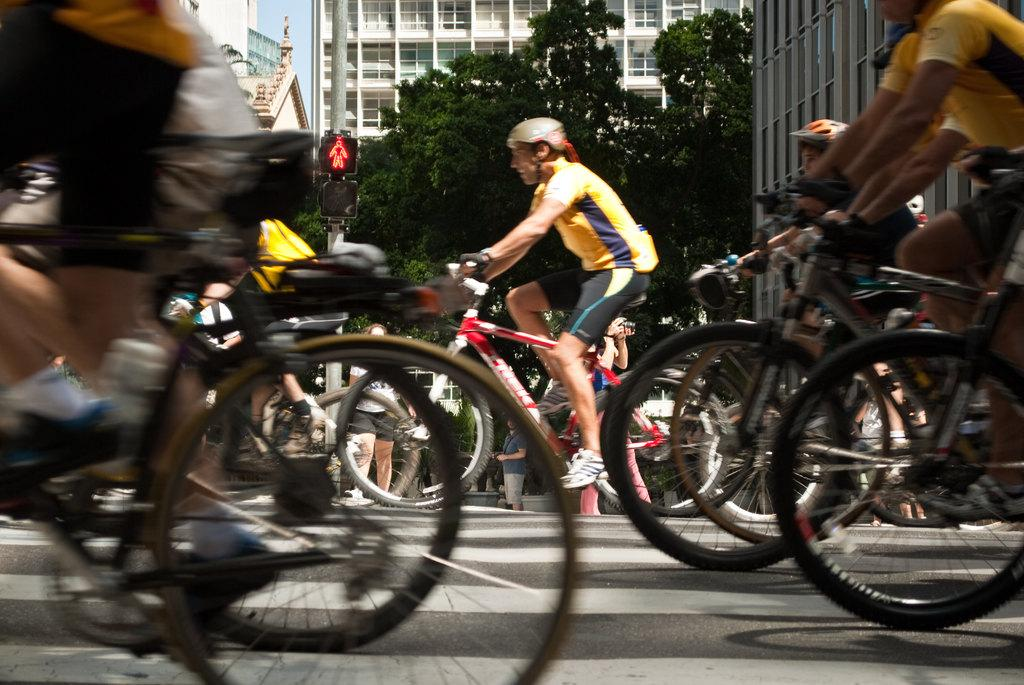What are the people in the image doing? The people in the image are riding bicycles on the road. What can be seen behind the people riding bicycles? There are trees and buildings behind the people riding bicycles. Can you see a river in the image? There is no river visible in the image. What type of shoe is the person riding the bicycle wearing? The image does not show the shoes of the people riding bicycles, so it cannot be determined from the image. 